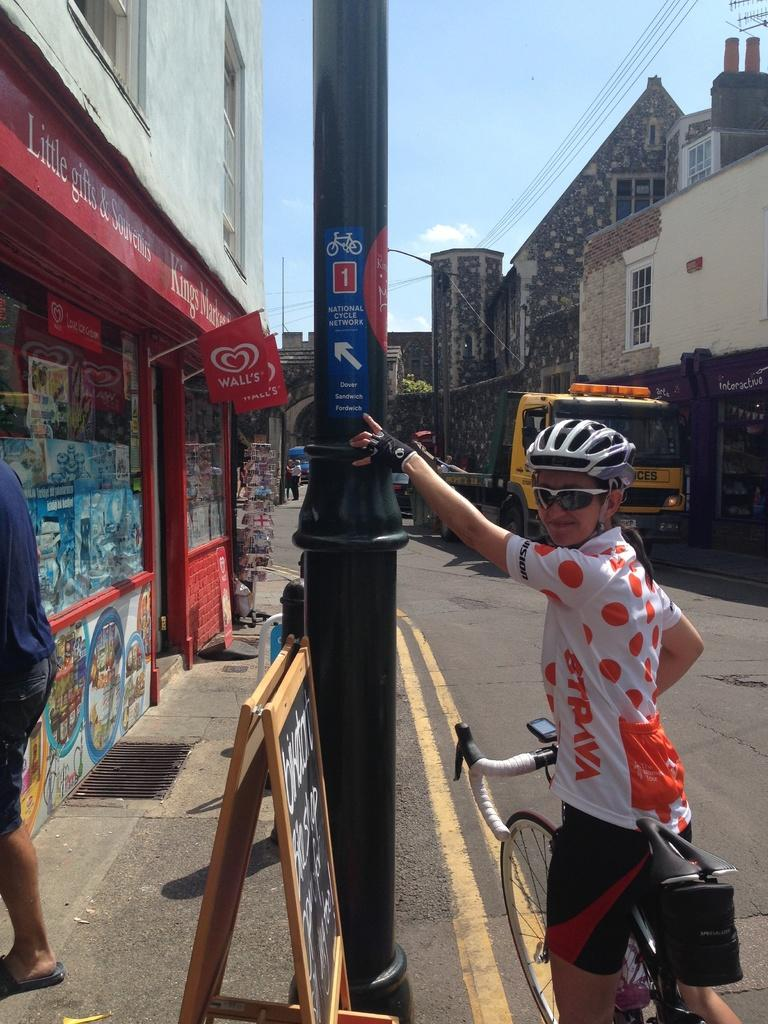Who is the main subject in the image? There is a boy in the image. What is the boy doing in the image? The boy is standing near a bicycle. What else can be seen near the boy? The boy is near a pole. What can be seen in the background of the image? There is a building, another person, a hoarding, and the sky visible in the background of the image. What type of scarecrow is standing next to the boy in the image? There is no scarecrow present in the image; it features a boy standing near a bicycle and a pole. Can you tell me how many tents are visible in the image? There are no tents present in the image. 